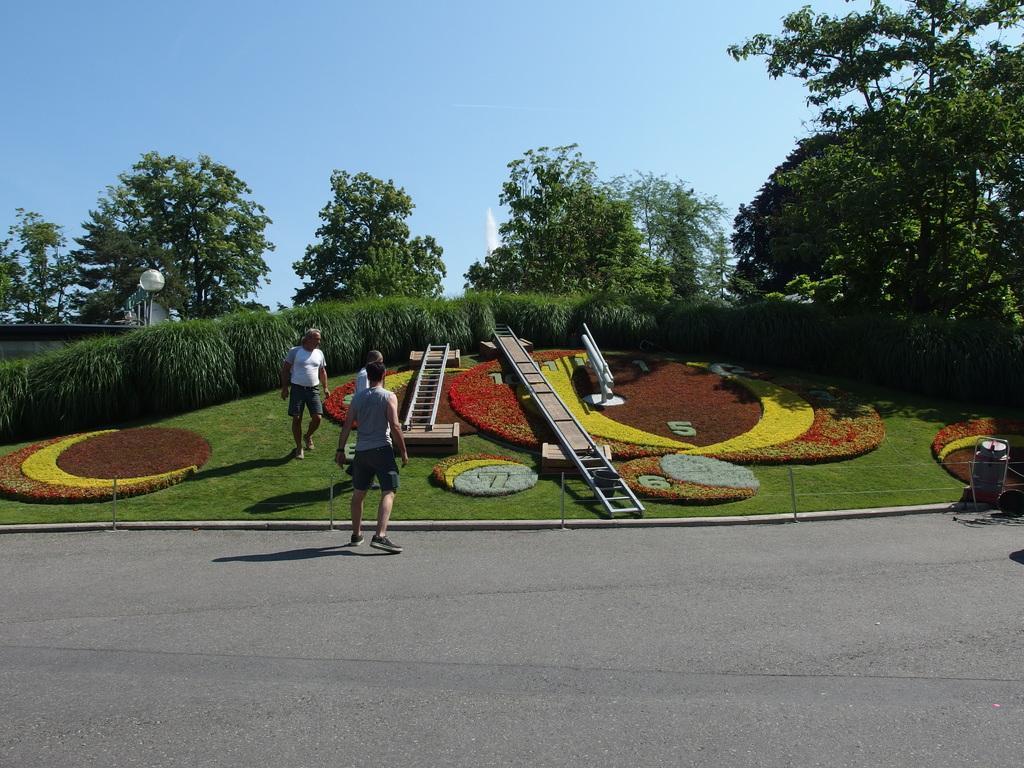In one or two sentences, can you explain what this image depicts? This picture is clicked outside. On the left we can see the group of persons seems to be walking on the ground. In the foreground we can see the concrete road. In the center we can see the grass and we can see the ladders and some other objects. In the background there is a sky, trees and shrubs and some other objects. 